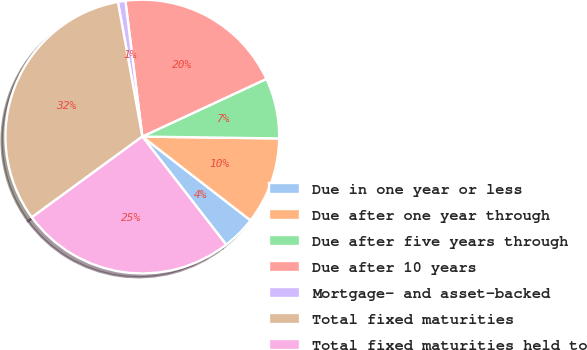Convert chart. <chart><loc_0><loc_0><loc_500><loc_500><pie_chart><fcel>Due in one year or less<fcel>Due after one year through<fcel>Due after five years through<fcel>Due after 10 years<fcel>Mortgage- and asset-backed<fcel>Total fixed maturities<fcel>Total fixed maturities held to<nl><fcel>4.01%<fcel>10.27%<fcel>7.14%<fcel>20.05%<fcel>0.88%<fcel>32.19%<fcel>25.45%<nl></chart> 